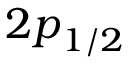<formula> <loc_0><loc_0><loc_500><loc_500>{ 2 p } _ { 1 / 2 }</formula> 